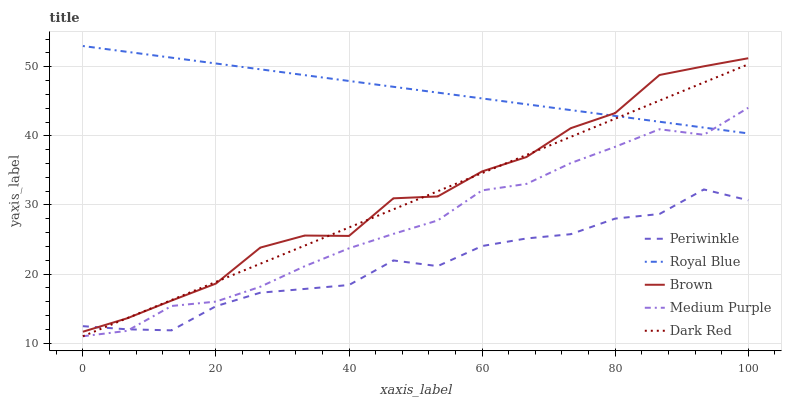Does Periwinkle have the minimum area under the curve?
Answer yes or no. Yes. Does Royal Blue have the maximum area under the curve?
Answer yes or no. Yes. Does Dark Red have the minimum area under the curve?
Answer yes or no. No. Does Dark Red have the maximum area under the curve?
Answer yes or no. No. Is Royal Blue the smoothest?
Answer yes or no. Yes. Is Brown the roughest?
Answer yes or no. Yes. Is Dark Red the smoothest?
Answer yes or no. No. Is Dark Red the roughest?
Answer yes or no. No. Does Medium Purple have the lowest value?
Answer yes or no. Yes. Does Royal Blue have the lowest value?
Answer yes or no. No. Does Royal Blue have the highest value?
Answer yes or no. Yes. Does Dark Red have the highest value?
Answer yes or no. No. Is Medium Purple less than Brown?
Answer yes or no. Yes. Is Royal Blue greater than Periwinkle?
Answer yes or no. Yes. Does Periwinkle intersect Medium Purple?
Answer yes or no. Yes. Is Periwinkle less than Medium Purple?
Answer yes or no. No. Is Periwinkle greater than Medium Purple?
Answer yes or no. No. Does Medium Purple intersect Brown?
Answer yes or no. No. 